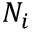<formula> <loc_0><loc_0><loc_500><loc_500>N _ { i }</formula> 